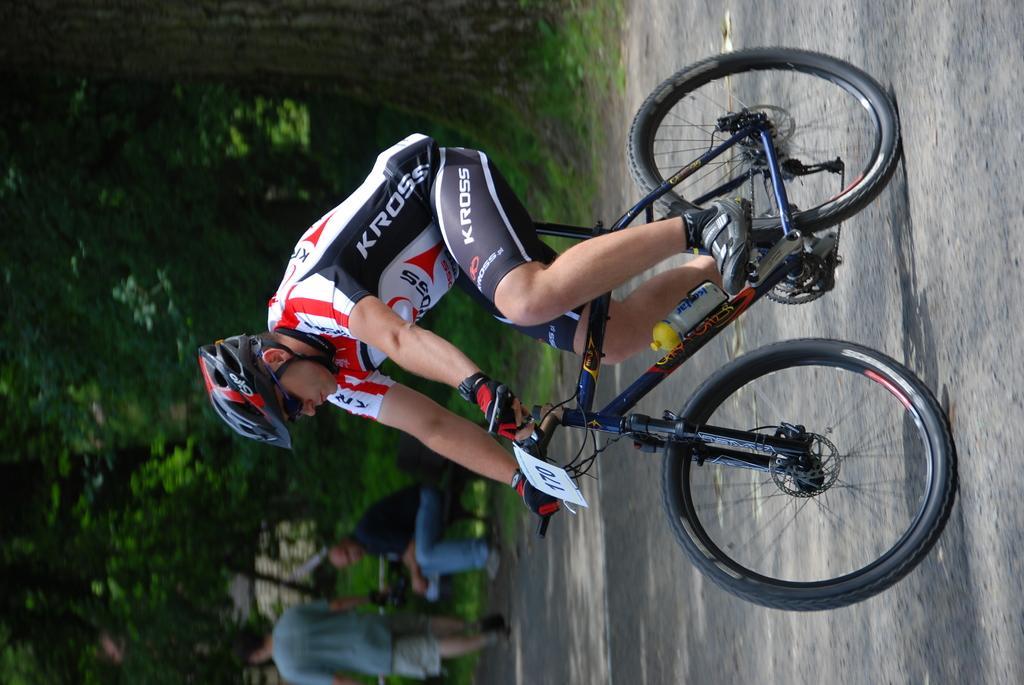Describe this image in one or two sentences. This picture describes about group of people, in the middle of the given image we can see a man, he is riding bicycle and he wore a helmet, in the background we can see few trees. 